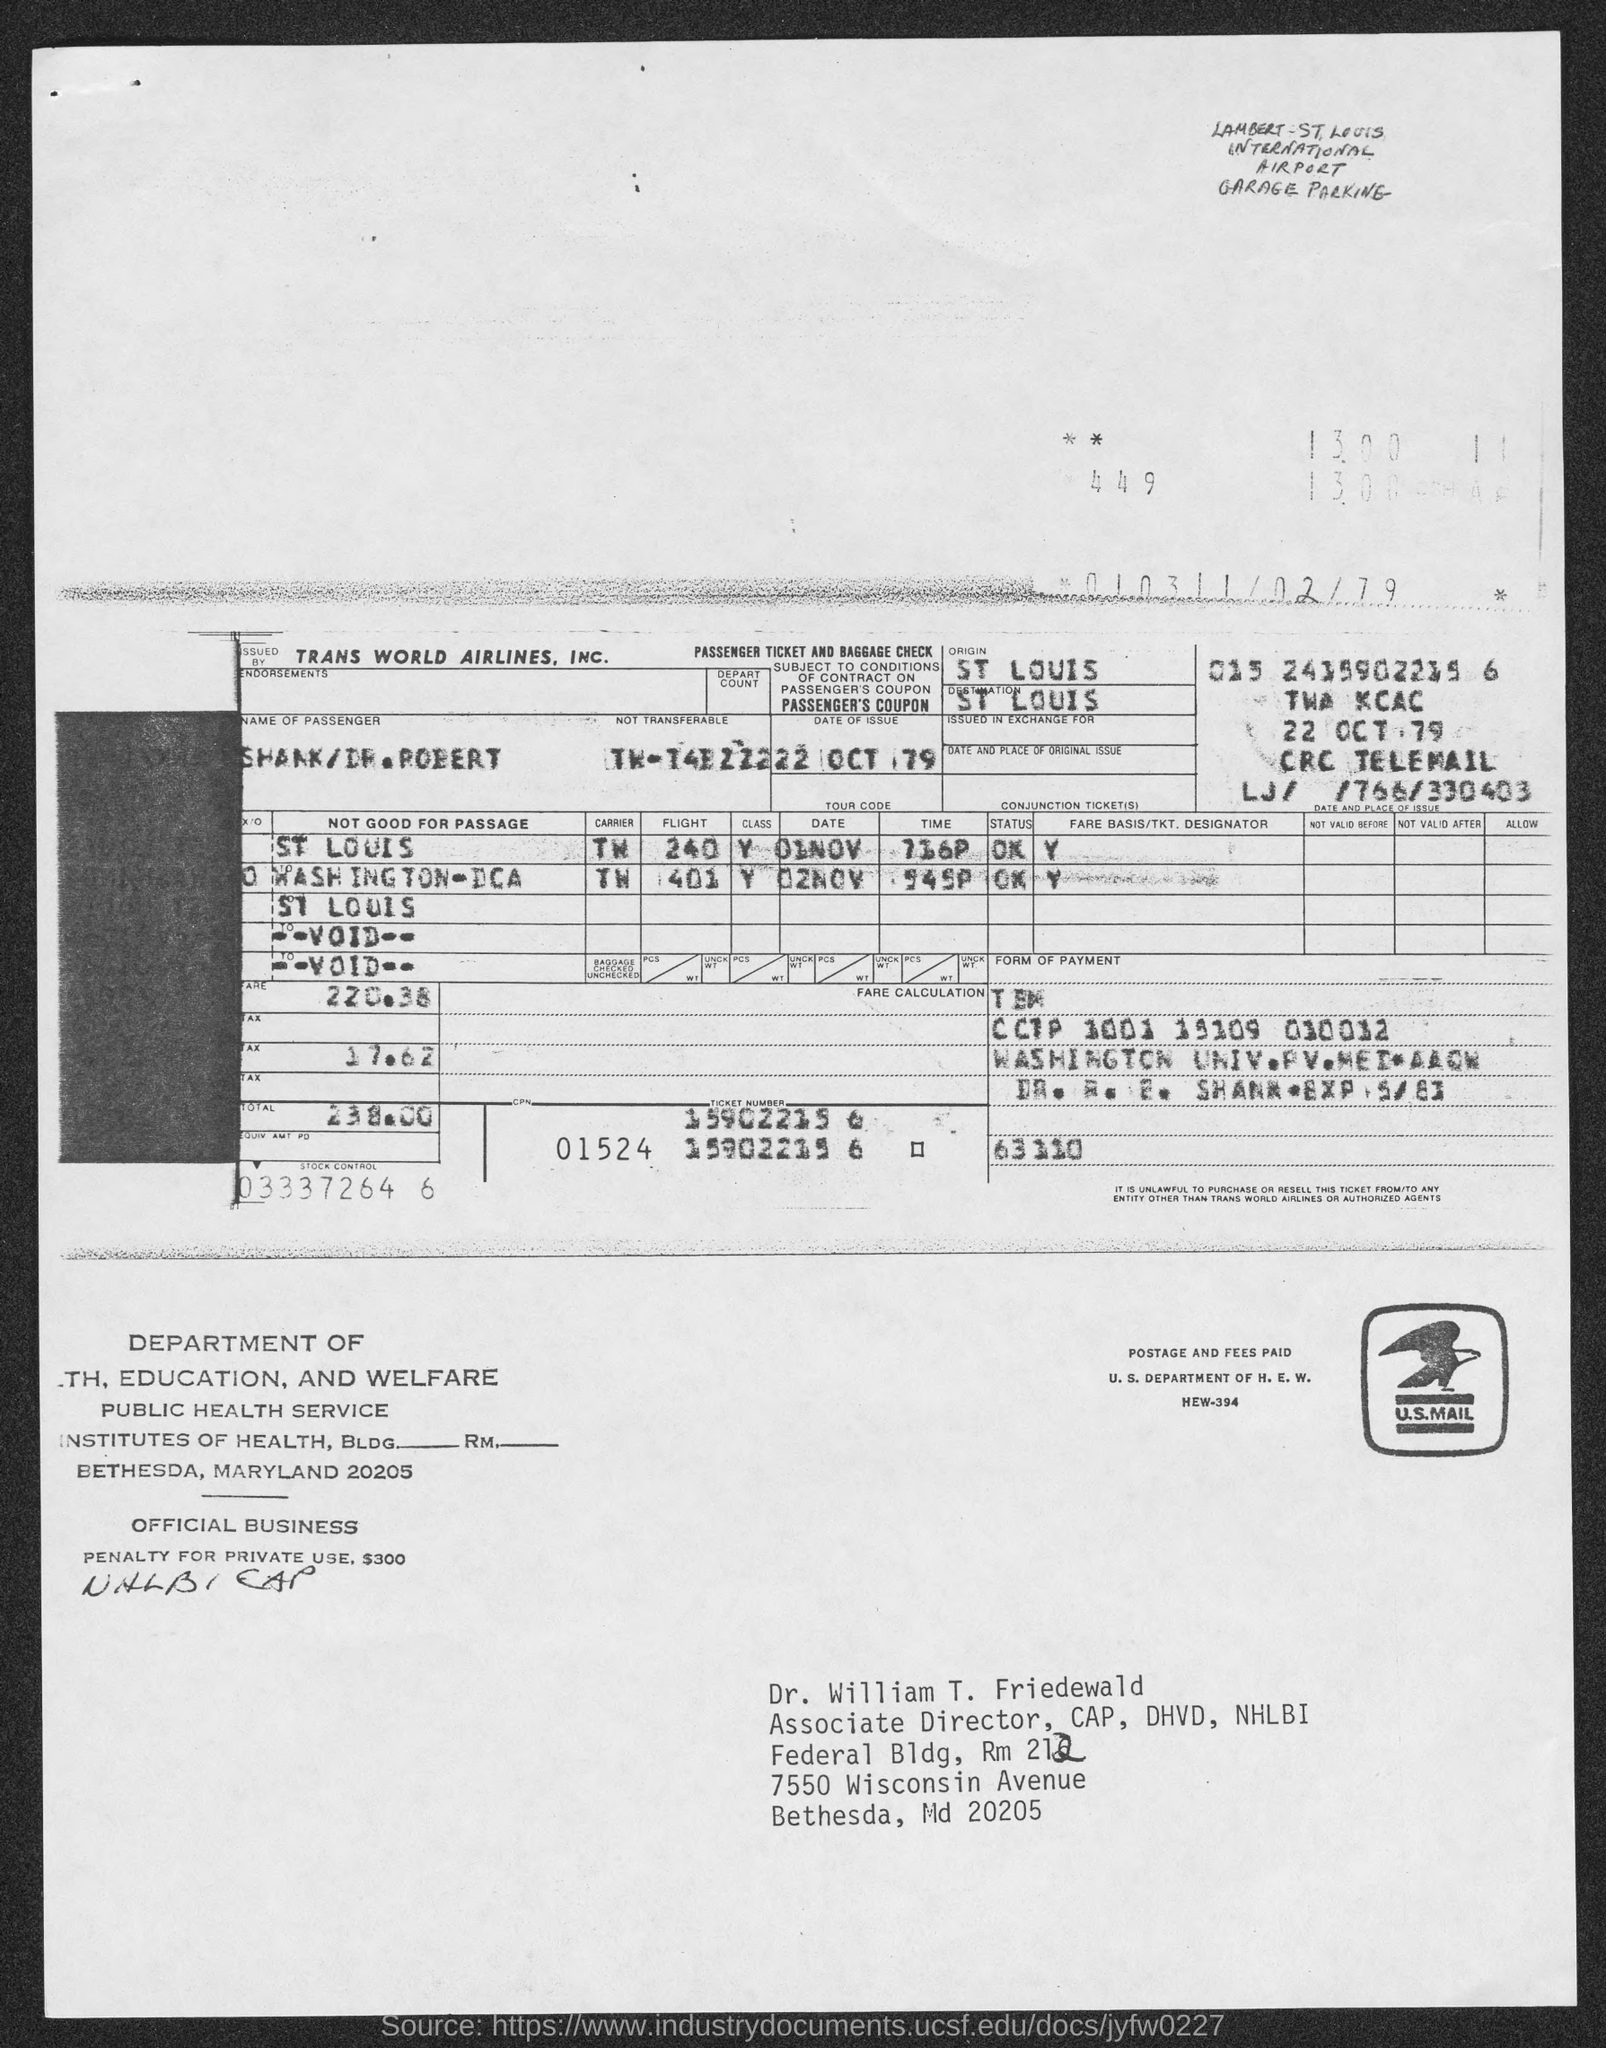List a handful of essential elements in this visual. The amount of tax mentioned in the given form is 17.62%. The destination mentioned in the given form is St. Louis. The fare mentioned in the given form is 220.38.. The total amount mentioned in the given form is 238.00... 